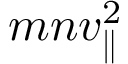Convert formula to latex. <formula><loc_0><loc_0><loc_500><loc_500>m n v _ { \| } ^ { 2 }</formula> 